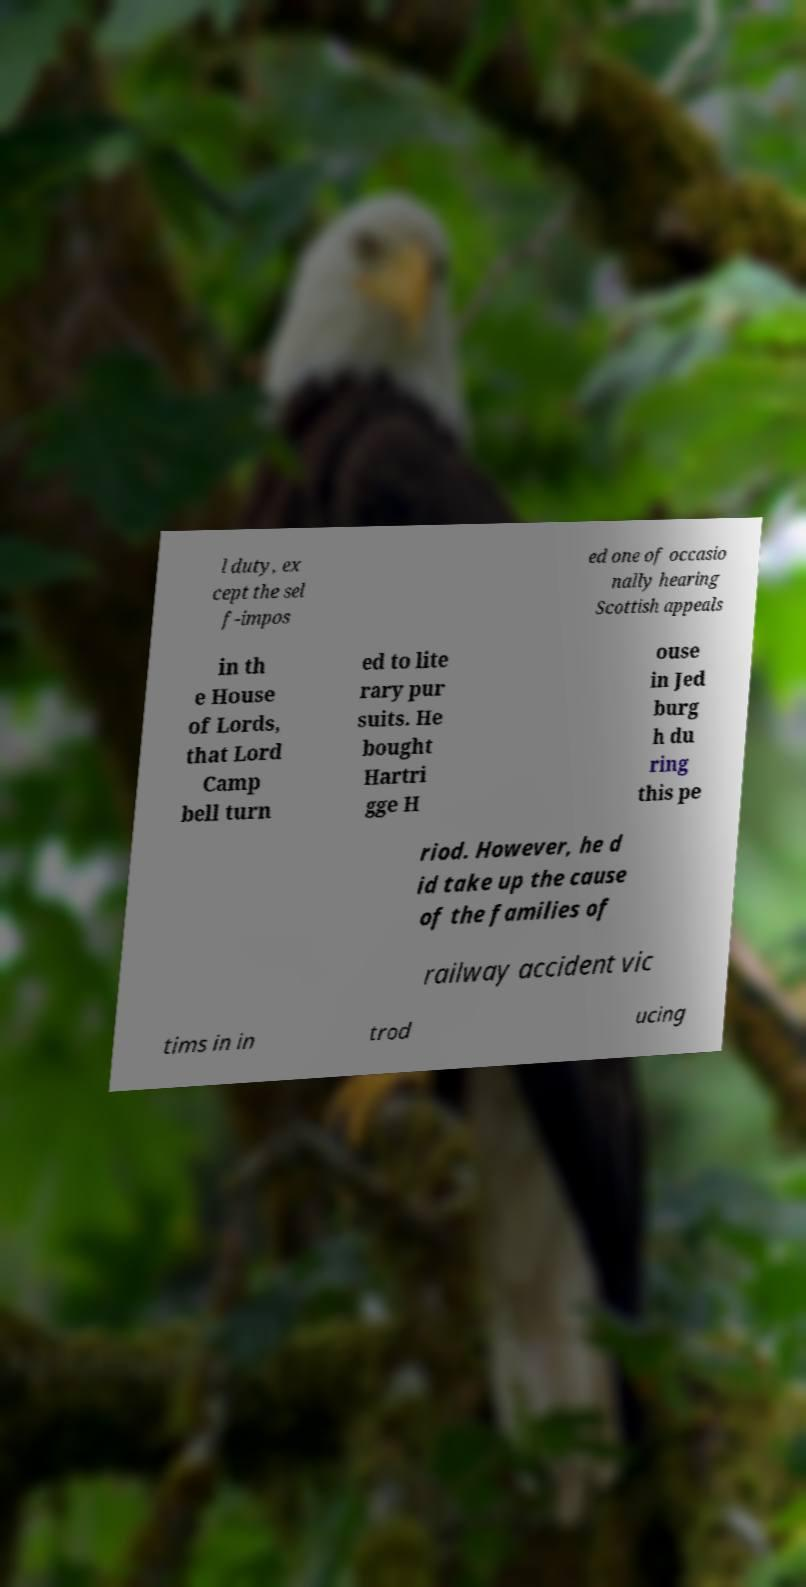Please read and relay the text visible in this image. What does it say? l duty, ex cept the sel f-impos ed one of occasio nally hearing Scottish appeals in th e House of Lords, that Lord Camp bell turn ed to lite rary pur suits. He bought Hartri gge H ouse in Jed burg h du ring this pe riod. However, he d id take up the cause of the families of railway accident vic tims in in trod ucing 